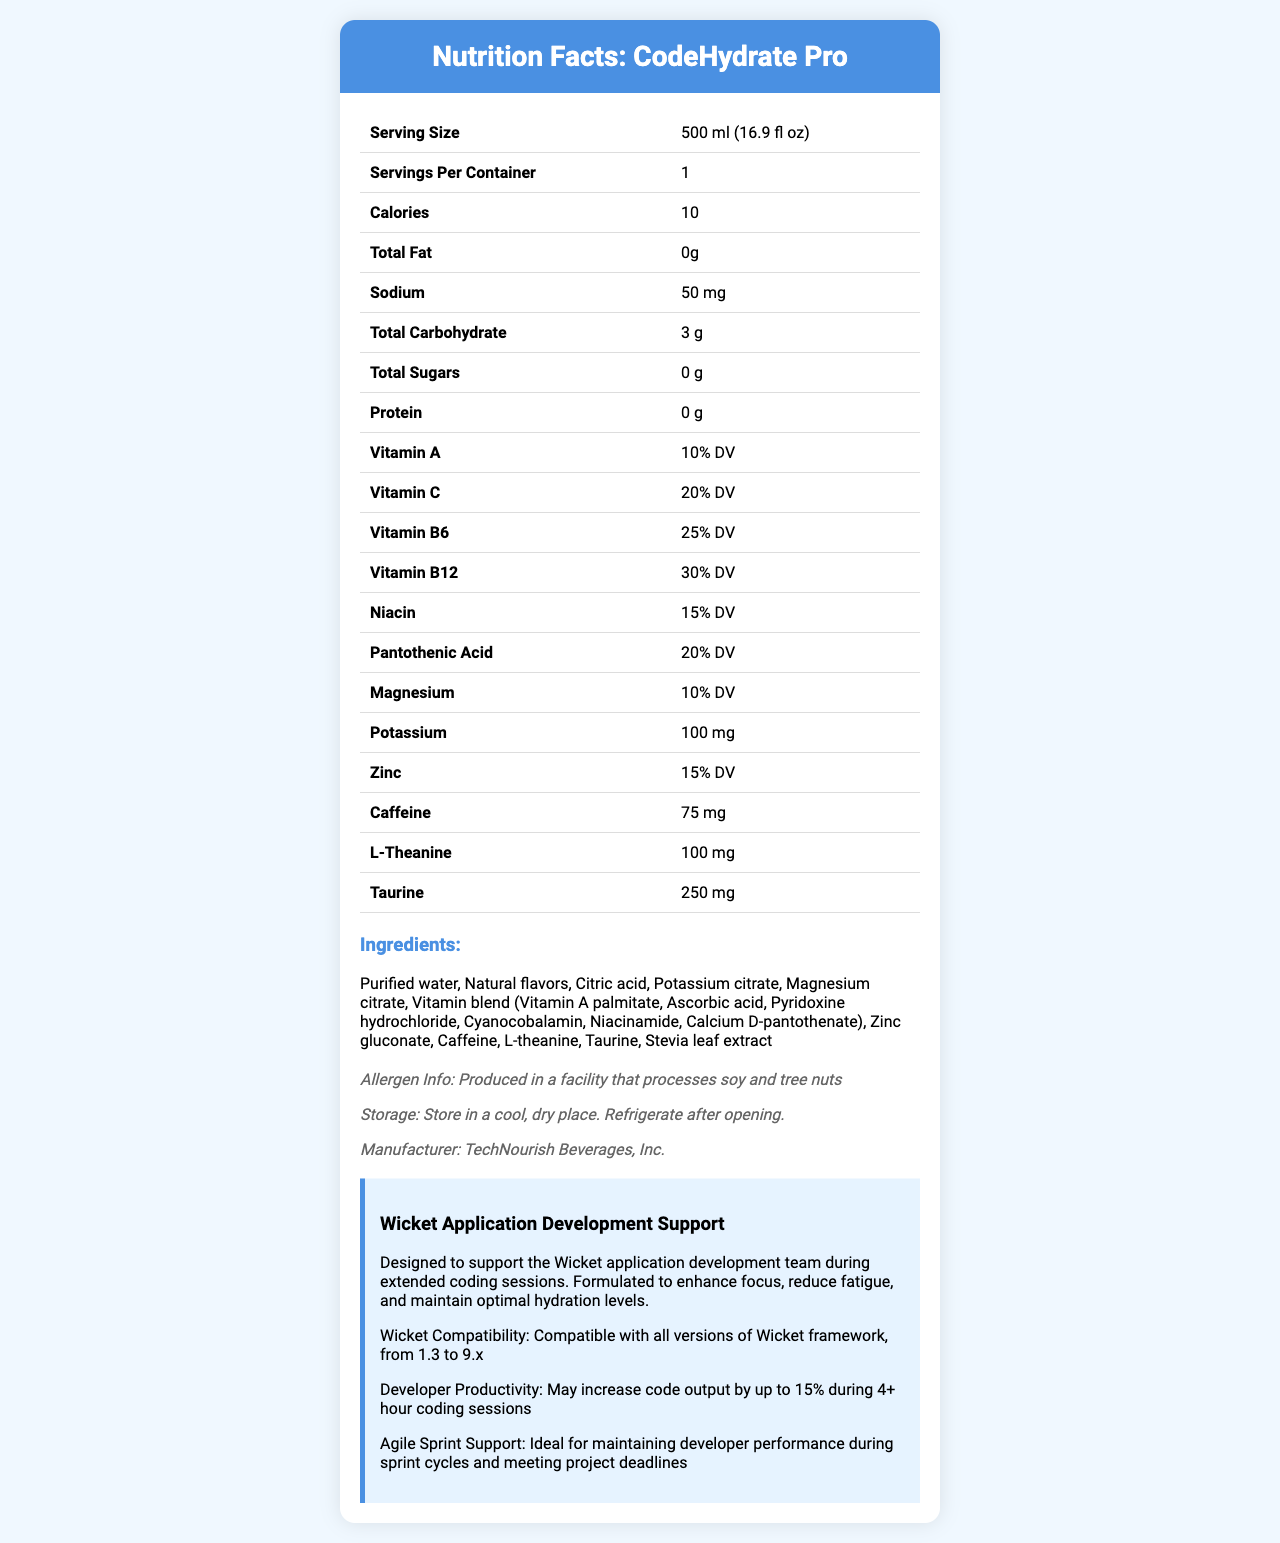what is the serving size of CodeHydrate Pro? The serving size is clearly stated in the beginning table of the document.
Answer: 500 ml (16.9 fl oz) how many calories are in a serving of CodeHydrate Pro? The calorie content per serving is listed in the nutrition facts table.
Answer: 10 does CodeHydrate Pro contain any fat? The total fat content listed is 0g, indicating there is no fat in the product.
Answer: No what are the main vitamins included in CodeHydrate Pro, and their respective daily values? The vitamins and their Daily Values (%DV) are enumerated in the table in the nutrition facts section.
Answer: Vitamin A (10% DV), Vitamin C (20% DV), Vitamin B6 (25% DV), Vitamin B12 (30% DV), Niacin (15% DV), Pantothenic Acid (20% DV) what is the amount of caffeine in CodeHydrate Pro? The amount of caffeine is listed as 75 mg in the nutrition facts section.
Answer: 75 mg how should CodeHydrate Pro be stored after opening? The storage information is provided in the notes section.
Answer: Refrigerate after opening who is the manufacturer of CodeHydrate Pro? The manufacturer details are listed in the notes section.
Answer: TechNourish Beverages, Inc. which of the following is NOT an ingredient in CodeHydrate Pro? A. Purified water B. Stevia leaf extract C. High fructose corn syrup The ingredient list does not include high fructose corn syrup.
Answer: C. High fructose corn syrup what is the percentage daily value of magnesium in CodeHydrate Pro? A. 5% B. 10% C. 15% D. 20% The percentage daily value of magnesium is listed as 10% in the nutrition facts section.
Answer: B. 10% is CodeHydrate Pro designed to support agile sprint cycles? The document mentions that CodeHydrate Pro is ideal for maintaining developer performance during sprint cycles and meeting project deadlines.
Answer: Yes summarize the main purpose of CodeHydrate Pro. The summary entails the product's focus on hydration, enhanced cognitive function, reduction of fatigue, and overall support for developers, with specific ingredients mentioned for added benefits.
Answer: CodeHydrate Pro is a vitamin-fortified bottled water designed to support hydration, enhance focus, reduce fatigue, and maintain optimal performance for developers during extended coding sessions. It is formulated with key vitamins, minerals, and other beneficial ingredients like caffeine, L-theanine, and taurine. what is the compatibility of CodeHydrate Pro with Wicket framework versions? The document states that CodeHydrate Pro is compatible with all versions of the Wicket framework from 1.3 to 9.x.
Answer: Compatible with all versions of Wicket framework, from 1.3 to 9.x how much potassium is in CodeHydrate Pro? The potassium content is listed in the nutrition facts section.
Answer: 100 mg can the specific percentage increase in code output be precisely determined from the document? While the document claims "may increase code output by up to 15% during 4+ hour coding sessions," it does not provide data or specific empirical evidence to verify this claim.
Answer: Cannot be determined does CodeHydrate Pro contain any sugars? The total sugars listed are 0g, indicating the product does not contain any sugars.
Answer: No under what conditions should CodeHydrate Pro be stored? The instructions for storage are provided in the notes section.
Answer: Store in a cool, dry place. Refrigerate after opening. how many servings per container are there in CodeHydrate Pro? The document states that there is 1 serving per container.
Answer: 1 